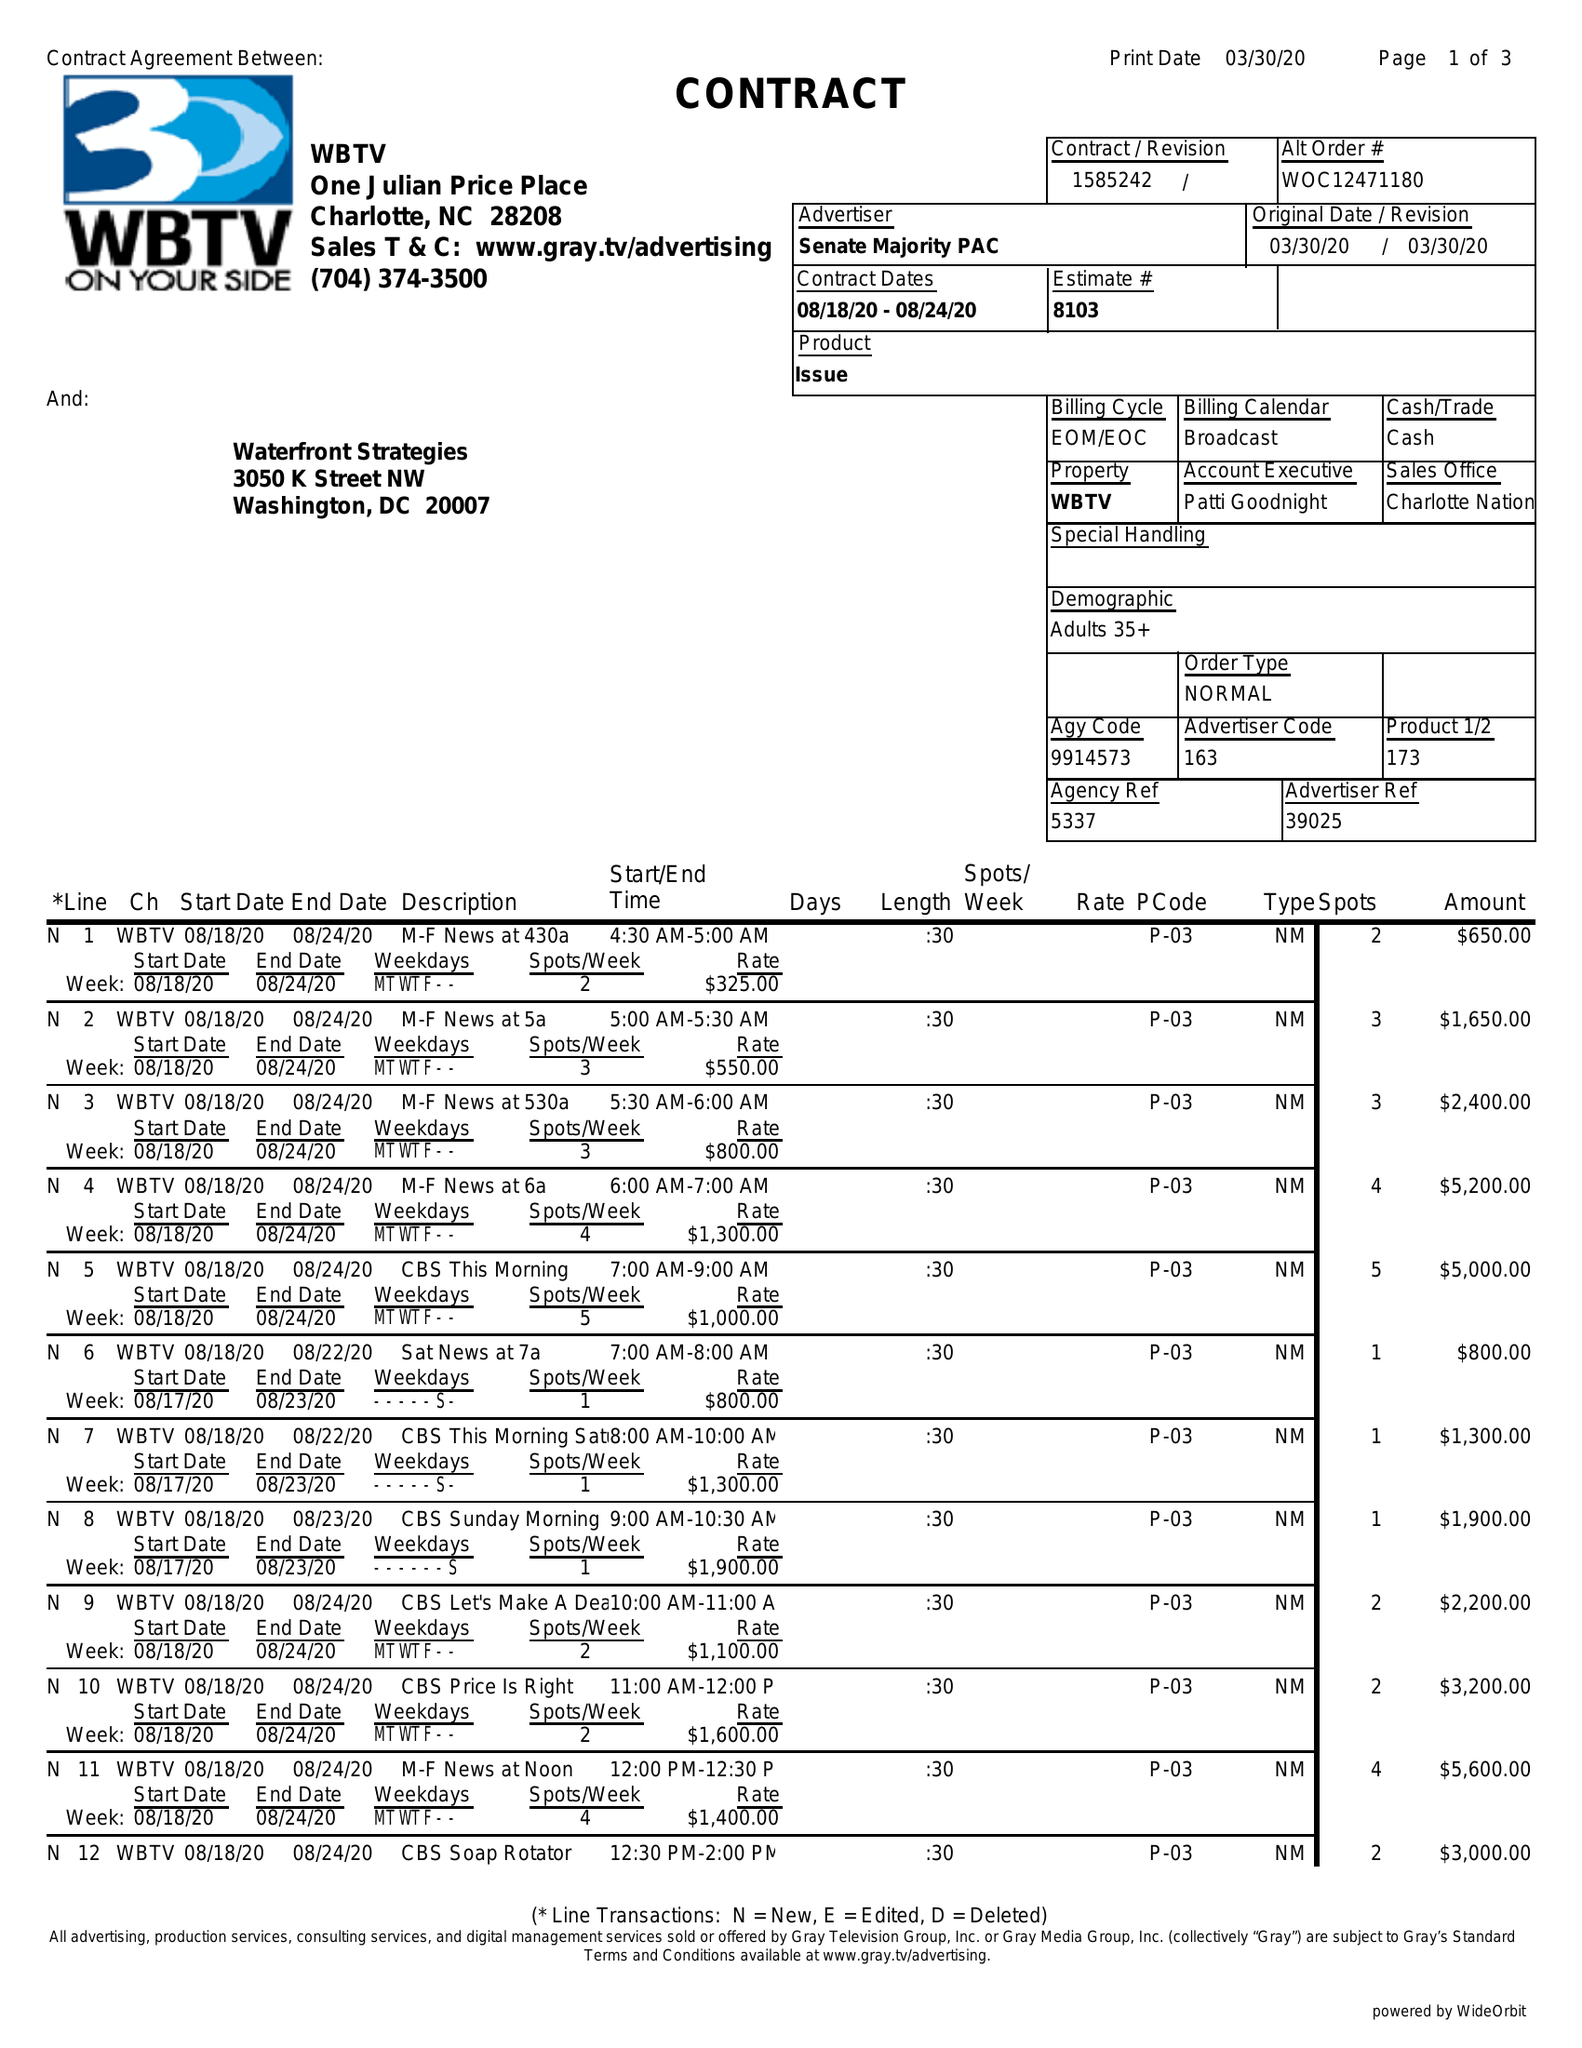What is the value for the flight_to?
Answer the question using a single word or phrase. 08/24/20 